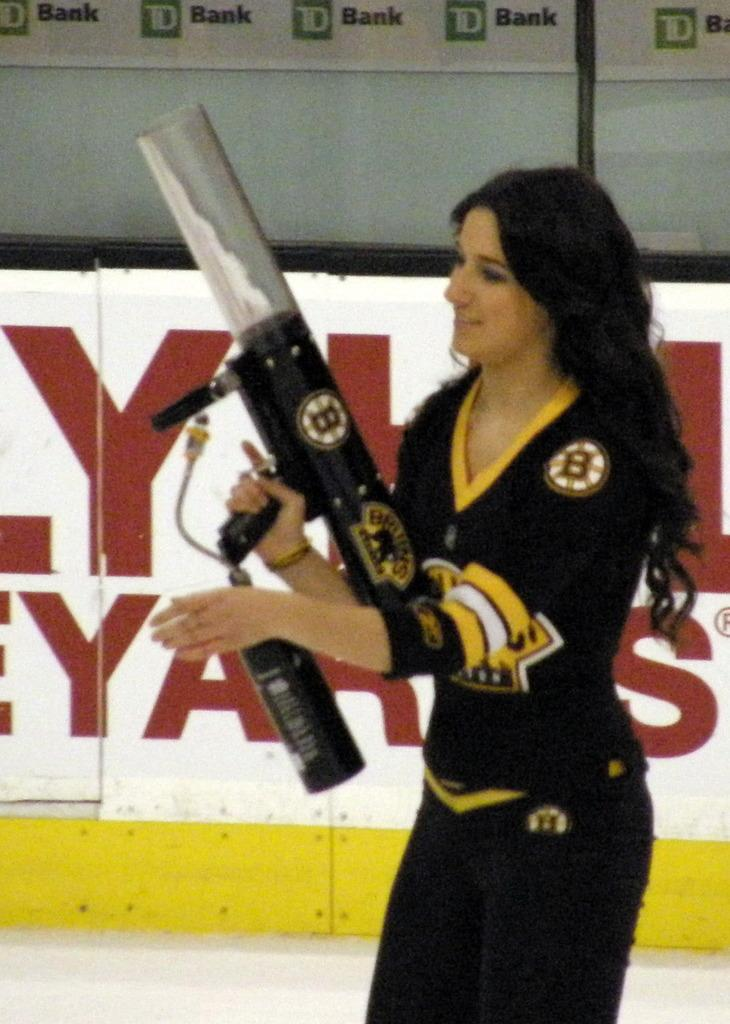What is the woman in the image doing? The woman is standing in the image and holding a gun. What can be seen in the background of the image? There is a banner in the background of the image. What language is the woman speaking in the image? There is no indication of the woman speaking in the image, so it cannot be determined which language she might be using. 